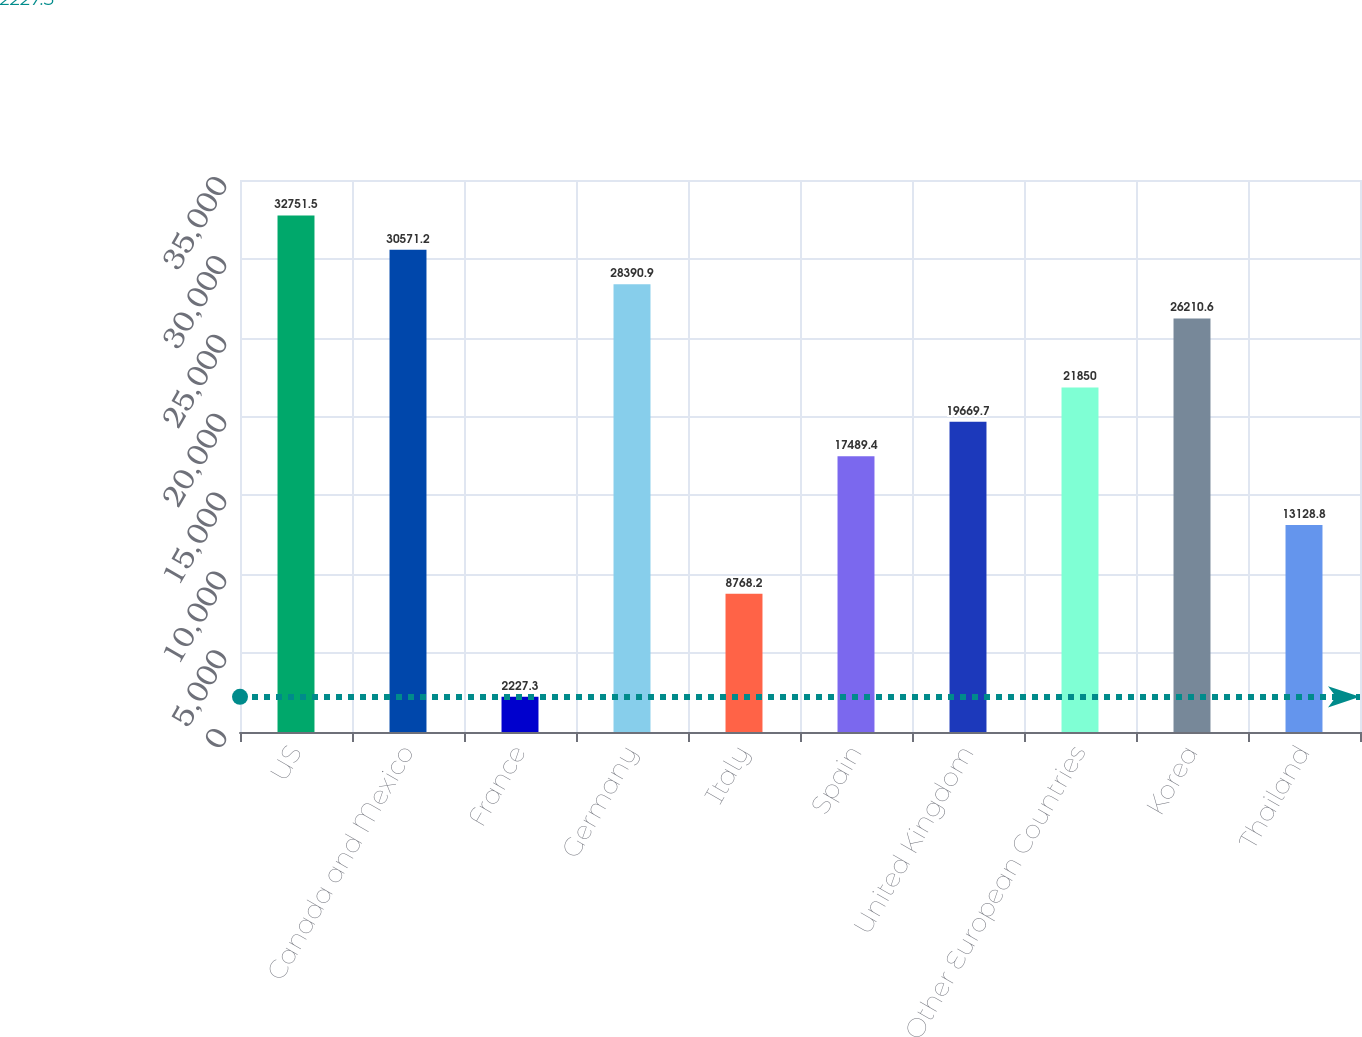<chart> <loc_0><loc_0><loc_500><loc_500><bar_chart><fcel>US<fcel>Canada and Mexico<fcel>France<fcel>Germany<fcel>Italy<fcel>Spain<fcel>United Kingdom<fcel>Other European Countries<fcel>Korea<fcel>Thailand<nl><fcel>32751.5<fcel>30571.2<fcel>2227.3<fcel>28390.9<fcel>8768.2<fcel>17489.4<fcel>19669.7<fcel>21850<fcel>26210.6<fcel>13128.8<nl></chart> 